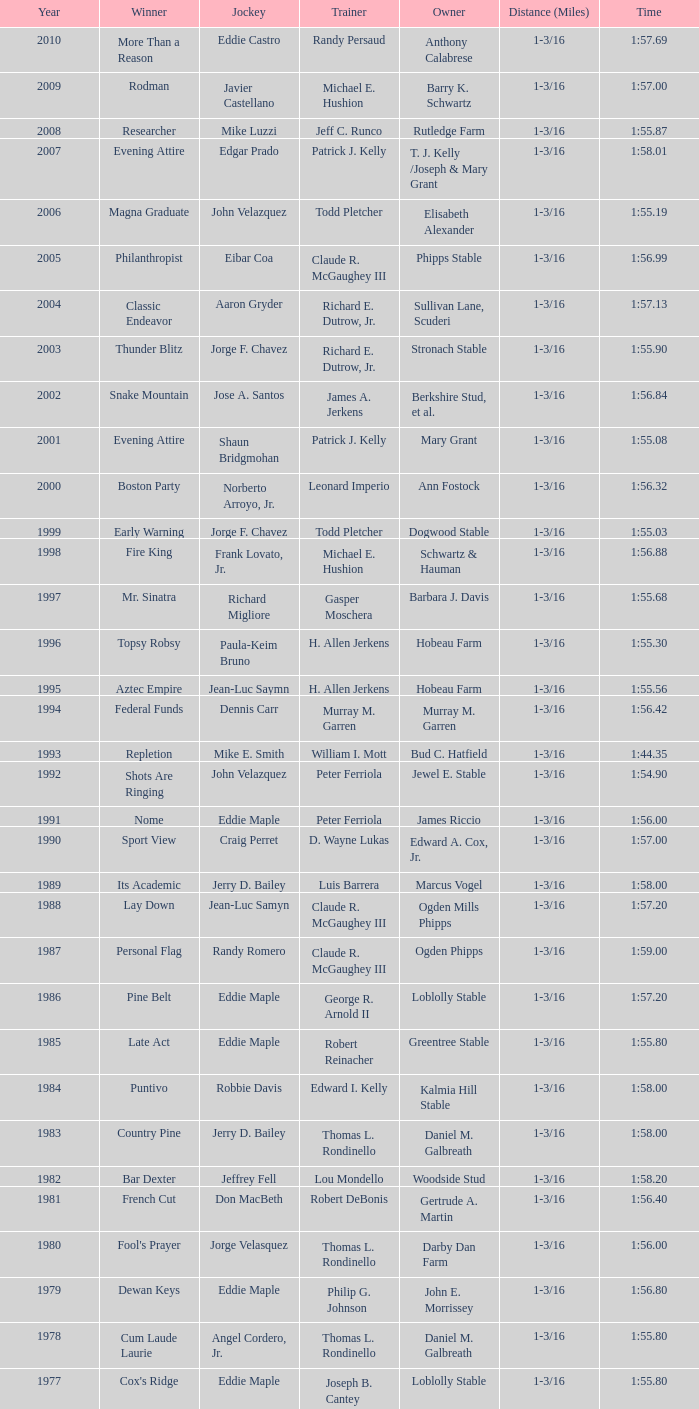Can you give me this table as a dict? {'header': ['Year', 'Winner', 'Jockey', 'Trainer', 'Owner', 'Distance (Miles)', 'Time'], 'rows': [['2010', 'More Than a Reason', 'Eddie Castro', 'Randy Persaud', 'Anthony Calabrese', '1-3/16', '1:57.69'], ['2009', 'Rodman', 'Javier Castellano', 'Michael E. Hushion', 'Barry K. Schwartz', '1-3/16', '1:57.00'], ['2008', 'Researcher', 'Mike Luzzi', 'Jeff C. Runco', 'Rutledge Farm', '1-3/16', '1:55.87'], ['2007', 'Evening Attire', 'Edgar Prado', 'Patrick J. Kelly', 'T. J. Kelly /Joseph & Mary Grant', '1-3/16', '1:58.01'], ['2006', 'Magna Graduate', 'John Velazquez', 'Todd Pletcher', 'Elisabeth Alexander', '1-3/16', '1:55.19'], ['2005', 'Philanthropist', 'Eibar Coa', 'Claude R. McGaughey III', 'Phipps Stable', '1-3/16', '1:56.99'], ['2004', 'Classic Endeavor', 'Aaron Gryder', 'Richard E. Dutrow, Jr.', 'Sullivan Lane, Scuderi', '1-3/16', '1:57.13'], ['2003', 'Thunder Blitz', 'Jorge F. Chavez', 'Richard E. Dutrow, Jr.', 'Stronach Stable', '1-3/16', '1:55.90'], ['2002', 'Snake Mountain', 'Jose A. Santos', 'James A. Jerkens', 'Berkshire Stud, et al.', '1-3/16', '1:56.84'], ['2001', 'Evening Attire', 'Shaun Bridgmohan', 'Patrick J. Kelly', 'Mary Grant', '1-3/16', '1:55.08'], ['2000', 'Boston Party', 'Norberto Arroyo, Jr.', 'Leonard Imperio', 'Ann Fostock', '1-3/16', '1:56.32'], ['1999', 'Early Warning', 'Jorge F. Chavez', 'Todd Pletcher', 'Dogwood Stable', '1-3/16', '1:55.03'], ['1998', 'Fire King', 'Frank Lovato, Jr.', 'Michael E. Hushion', 'Schwartz & Hauman', '1-3/16', '1:56.88'], ['1997', 'Mr. Sinatra', 'Richard Migliore', 'Gasper Moschera', 'Barbara J. Davis', '1-3/16', '1:55.68'], ['1996', 'Topsy Robsy', 'Paula-Keim Bruno', 'H. Allen Jerkens', 'Hobeau Farm', '1-3/16', '1:55.30'], ['1995', 'Aztec Empire', 'Jean-Luc Saymn', 'H. Allen Jerkens', 'Hobeau Farm', '1-3/16', '1:55.56'], ['1994', 'Federal Funds', 'Dennis Carr', 'Murray M. Garren', 'Murray M. Garren', '1-3/16', '1:56.42'], ['1993', 'Repletion', 'Mike E. Smith', 'William I. Mott', 'Bud C. Hatfield', '1-3/16', '1:44.35'], ['1992', 'Shots Are Ringing', 'John Velazquez', 'Peter Ferriola', 'Jewel E. Stable', '1-3/16', '1:54.90'], ['1991', 'Nome', 'Eddie Maple', 'Peter Ferriola', 'James Riccio', '1-3/16', '1:56.00'], ['1990', 'Sport View', 'Craig Perret', 'D. Wayne Lukas', 'Edward A. Cox, Jr.', '1-3/16', '1:57.00'], ['1989', 'Its Academic', 'Jerry D. Bailey', 'Luis Barrera', 'Marcus Vogel', '1-3/16', '1:58.00'], ['1988', 'Lay Down', 'Jean-Luc Samyn', 'Claude R. McGaughey III', 'Ogden Mills Phipps', '1-3/16', '1:57.20'], ['1987', 'Personal Flag', 'Randy Romero', 'Claude R. McGaughey III', 'Ogden Phipps', '1-3/16', '1:59.00'], ['1986', 'Pine Belt', 'Eddie Maple', 'George R. Arnold II', 'Loblolly Stable', '1-3/16', '1:57.20'], ['1985', 'Late Act', 'Eddie Maple', 'Robert Reinacher', 'Greentree Stable', '1-3/16', '1:55.80'], ['1984', 'Puntivo', 'Robbie Davis', 'Edward I. Kelly', 'Kalmia Hill Stable', '1-3/16', '1:58.00'], ['1983', 'Country Pine', 'Jerry D. Bailey', 'Thomas L. Rondinello', 'Daniel M. Galbreath', '1-3/16', '1:58.00'], ['1982', 'Bar Dexter', 'Jeffrey Fell', 'Lou Mondello', 'Woodside Stud', '1-3/16', '1:58.20'], ['1981', 'French Cut', 'Don MacBeth', 'Robert DeBonis', 'Gertrude A. Martin', '1-3/16', '1:56.40'], ['1980', "Fool's Prayer", 'Jorge Velasquez', 'Thomas L. Rondinello', 'Darby Dan Farm', '1-3/16', '1:56.00'], ['1979', 'Dewan Keys', 'Eddie Maple', 'Philip G. Johnson', 'John E. Morrissey', '1-3/16', '1:56.80'], ['1978', 'Cum Laude Laurie', 'Angel Cordero, Jr.', 'Thomas L. Rondinello', 'Daniel M. Galbreath', '1-3/16', '1:55.80'], ['1977', "Cox's Ridge", 'Eddie Maple', 'Joseph B. Cantey', 'Loblolly Stable', '1-3/16', '1:55.80'], ['1976', "It's Freezing", 'Jacinto Vasquez', 'Anthony Basile', 'Bwamazon Farm', '1-3/16', '1:56.60'], ['1975', 'Hail The Pirates', 'Ron Turcotte', 'Thomas L. Rondinello', 'Daniel M. Galbreath', '1-3/16', '1:55.60'], ['1974', 'Free Hand', 'Jose Amy', 'Pancho Martin', 'Sigmund Sommer', '1-3/16', '1:55.00'], ['1973', 'True Knight', 'Angel Cordero, Jr.', 'Thomas L. Rondinello', 'Darby Dan Farm', '1-3/16', '1:55.00'], ['1972', 'Sunny And Mild', 'Michael Venezia', 'W. Preston King', 'Harry Rogosin', '1-3/16', '1:54.40'], ['1971', 'Red Reality', 'Jorge Velasquez', 'MacKenzie Miller', 'Cragwood Stables', '1-1/8', '1:49.60'], ['1970', 'Best Turn', 'Larry Adams', 'Reggie Cornell', 'Calumet Farm', '1-1/8', '1:50.00'], ['1969', 'Vif', 'Larry Adams', 'Clarence Meaux', 'Harvey Peltier', '1-1/8', '1:49.20'], ['1968', 'Irish Dude', 'Sandino Hernandez', 'Jack Bradley', 'Richard W. Taylor', '1-1/8', '1:49.60'], ['1967', 'Mr. Right', 'Heliodoro Gustines', 'Evan S. Jackson', 'Mrs. Peter Duchin', '1-1/8', '1:49.60'], ['1966', 'Amberoid', 'Walter Blum', 'Lucien Laurin', 'Reginald N. Webster', '1-1/8', '1:50.60'], ['1965', 'Prairie Schooner', 'Eddie Belmonte', 'James W. Smith', 'High Tide Stable', '1-1/8', '1:50.20'], ['1964', 'Third Martini', 'William Boland', 'H. Allen Jerkens', 'Hobeau Farm', '1-1/8', '1:50.60'], ['1963', 'Uppercut', 'Manuel Ycaza', 'Willard C. Freeman', 'William Harmonay', '1-1/8', '1:35.40'], ['1962', 'Grid Iron Hero', 'Manuel Ycaza', 'Laz Barrera', 'Emil Dolce', '1 mile', '1:34.00'], ['1961', 'Manassa Mauler', 'Braulio Baeza', 'Pancho Martin', 'Emil Dolce', '1 mile', '1:36.20'], ['1960', 'Cranberry Sauce', 'Heliodoro Gustines', 'not found', 'Elmendorf Farm', '1 mile', '1:36.20'], ['1959', 'Whitley', 'Eric Guerin', 'Max Hirsch', 'W. Arnold Hanger', '1 mile', '1:36.40'], ['1958', 'Oh Johnny', 'William Boland', 'Norman R. McLeod', 'Mrs. Wallace Gilroy', '1-1/16', '1:43.40'], ['1957', 'Bold Ruler', 'Eddie Arcaro', 'James E. Fitzsimmons', 'Wheatley Stable', '1-1/16', '1:42.80'], ['1956', 'Blessbull', 'Willie Lester', 'not found', 'Morris Sims', '1-1/16', '1:42.00'], ['1955', 'Fabulist', 'Ted Atkinson', 'William C. Winfrey', 'High Tide Stable', '1-1/16', '1:43.60'], ['1954', 'Find', 'Eric Guerin', 'William C. Winfrey', 'Alfred G. Vanderbilt II', '1-1/16', '1:44.00'], ['1953', 'Flaunt', 'S. Cole', 'Hubert W. Williams', 'Arnold Skjeveland', '1-1/16', '1:44.20'], ['1952', 'County Delight', 'Dave Gorman', 'James E. Ryan', 'Rokeby Stable', '1-1/16', '1:43.60'], ['1951', 'Sheilas Reward', 'Ovie Scurlock', 'Eugene Jacobs', 'Mrs. Louis Lazare', '1-1/16', '1:44.60'], ['1950', 'Three Rings', 'Hedley Woodhouse', 'Willie Knapp', 'Mrs. Evelyn L. Hopkins', '1-1/16', '1:44.60'], ['1949', 'Three Rings', 'Ted Atkinson', 'Willie Knapp', 'Mrs. Evelyn L. Hopkins', '1-1/16', '1:47.40'], ['1948', 'Knockdown', 'Ferrill Zufelt', 'Tom Smith', 'Maine Chance Farm', '1-1/16', '1:44.60'], ['1947', 'Gallorette', 'Job Dean Jessop', 'Edward A. Christmas', 'William L. Brann', '1-1/16', '1:45.40'], ['1946', 'Helioptic', 'Paul Miller', 'not found', 'William Goadby Loew', '1-1/16', '1:43.20'], ['1945', 'Olympic Zenith', 'Conn McCreary', 'Willie Booth', 'William G. Helis', '1-1/16', '1:45.60'], ['1944', 'First Fiddle', 'Johnny Longden', 'Edward Mulrenan', 'Mrs. Edward Mulrenan', '1-1/16', '1:44.20'], ['1943', 'The Rhymer', 'Conn McCreary', 'John M. Gaver, Sr.', 'Greentree Stable', '1-1/16', '1:45.00'], ['1942', 'Waller', 'Billie Thompson', 'A. G. Robertson', 'John C. Clark', '1-1/16', '1:44.00'], ['1941', 'Salford II', 'Don Meade', 'not found', 'Ralph B. Strassburger', '1-1/16', '1:44.20'], ['1940', 'He Did', 'Eddie Arcaro', 'J. Thomas Taylor', 'W. Arnold Hanger', '1-1/16', '1:43.20'], ['1939', 'Lovely Night', 'Johnny Longden', 'Henry McDaniel', 'Mrs. F. Ambrose Clark', '1 mile', '1:36.40'], ['1938', 'War Admiral', 'Charles Kurtsinger', 'George Conway', 'Glen Riddle Farm', '1 mile', '1:36.80'], ['1937', 'Snark', 'Johnny Longden', 'James E. Fitzsimmons', 'Wheatley Stable', '1 mile', '1:37.40'], ['1936', 'Good Gamble', 'Samuel Renick', 'Bud Stotler', 'Alfred G. Vanderbilt II', '1 mile', '1:37.20'], ['1935', 'King Saxon', 'Calvin Rainey', 'Charles Shaw', 'C. H. Knebelkamp', '1 mile', '1:37.20'], ['1934', 'Singing Wood', 'Robert Jones', 'James W. Healy', 'Liz Whitney', '1 mile', '1:38.60'], ['1933', 'Kerry Patch', 'Robert Wholey', 'Joseph A. Notter', 'Lee Rosenberg', '1 mile', '1:38.00'], ['1932', 'Halcyon', 'Hank Mills', 'T. J. Healey', 'C. V. Whitney', '1 mile', '1:38.00'], ['1931', 'Halcyon', 'G. Rose', 'T. J. Healey', 'C. V. Whitney', '1 mile', '1:38.40'], ['1930', 'Kildare', 'John Passero', 'Norman Tallman', 'Newtondale Stable', '1 mile', '1:38.60'], ['1929', 'Comstockery', 'Sidney Hebert', 'Thomas W. Murphy', 'Greentree Stable', '1 mile', '1:39.60'], ['1928', 'Kentucky II', 'George Schreiner', 'Max Hirsch', 'A. Charles Schwartz', '1 mile', '1:38.80'], ['1927', 'Light Carbine', 'James McCoy', 'M. J. Dunlevy', 'I. B. Humphreys', '1 mile', '1:36.80'], ['1926', 'Macaw', 'Linus McAtee', 'James G. Rowe, Sr.', 'Harry Payne Whitney', '1 mile', '1:37.00'], ['1925', 'Mad Play', 'Laverne Fator', 'Sam Hildreth', 'Rancocas Stable', '1 mile', '1:36.60'], ['1924', 'Mad Hatter', 'Earl Sande', 'Sam Hildreth', 'Rancocas Stable', '1 mile', '1:36.60'], ['1923', 'Zev', 'Earl Sande', 'Sam Hildreth', 'Rancocas Stable', '1 mile', '1:37.00'], ['1922', 'Grey Lag', 'Laverne Fator', 'Sam Hildreth', 'Rancocas Stable', '1 mile', '1:38.00'], ['1921', 'John P. Grier', 'Frank Keogh', 'James G. Rowe, Sr.', 'Harry Payne Whitney', '1 mile', '1:36.00'], ['1920', 'Cirrus', 'Lavelle Ensor', 'Sam Hildreth', 'Sam Hildreth', '1 mile', '1:38.00'], ['1919', 'Star Master', 'Merritt Buxton', 'Walter B. Jennings', 'A. Kingsley Macomber', '1 mile', '1:37.60'], ['1918', 'Roamer', 'Lawrence Lyke', 'A. J. Goldsborough', 'Andrew Miller', '1 mile', '1:36.60'], ['1917', 'Old Rosebud', 'Frank Robinson', 'Frank D. Weir', 'F. D. Weir & Hamilton C. Applegate', '1 mile', '1:37.60'], ['1916', 'Short Grass', 'Frank Keogh', 'not found', 'Emil Herz', '1 mile', '1:36.40'], ['1915', 'Roamer', 'James Butwell', 'A. J. Goldsborough', 'Andrew Miller', '1 mile', '1:39.20'], ['1914', 'Flying Fairy', 'Tommy Davies', 'J. Simon Healy', 'Edward B. Cassatt', '1 mile', '1:42.20'], ['1913', 'No Race', 'No Race', 'No Race', 'No Race', '1 mile', 'no race'], ['1912', 'No Race', 'No Race', 'No Race', 'No Race', '1 mile', 'no race'], ['1911', 'No Race', 'No Race', 'No Race', 'No Race', '1 mile', 'no race'], ['1910', 'Arasee', 'Buddy Glass', 'Andrew G. Blakely', 'Samuel Emery', '1 mile', '1:39.80'], ['1909', 'No Race', 'No Race', 'No Race', 'No Race', '1 mile', 'no race'], ['1908', 'Jack Atkin', 'Phil Musgrave', 'Herman R. Brandt', 'Barney Schreiber', '1 mile', '1:39.00'], ['1907', 'W. H. Carey', 'George Mountain', 'James Blute', 'Richard F. Carman', '1 mile', '1:40.00'], ['1906', "Ram's Horn", 'L. Perrine', 'W. S. "Jim" Williams', 'W. S. "Jim" Williams', '1 mile', '1:39.40'], ['1905', 'St. Valentine', 'William Crimmins', 'John Shields', 'Alexander Shields', '1 mile', '1:39.20'], ['1904', 'Rosetint', 'Thomas H. Burns', 'James Boden', 'John Boden', '1 mile', '1:39.20'], ['1903', 'Yellow Tail', 'Willie Shaw', 'H. E. Rowell', 'John Hackett', '1m 70yds', '1:45.20'], ['1902', 'Margravite', 'Otto Wonderly', 'not found', 'Charles Fleischmann Sons', '1m 70 yds', '1:46.00']]} Who was the rider for the victorious horse helioptic? Paul Miller. 